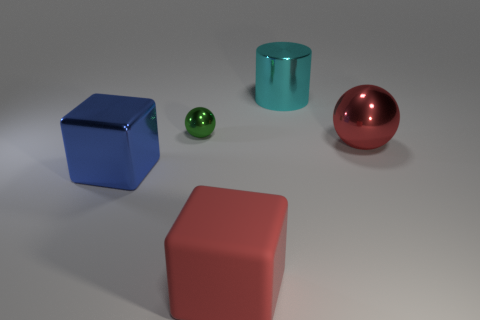Does the small thing have the same color as the large cube that is to the right of the green object?
Give a very brief answer. No. What is the color of the big rubber thing?
Give a very brief answer. Red. There is a ball in front of the tiny green object; what is it made of?
Provide a succinct answer. Metal. The red metal thing that is the same shape as the small green thing is what size?
Offer a very short reply. Large. Is the number of red metal balls behind the green metallic ball less than the number of big red rubber objects?
Offer a very short reply. Yes. Is there a large cyan metallic sphere?
Provide a short and direct response. No. What is the color of the metallic object that is the same shape as the red rubber object?
Keep it short and to the point. Blue. There is a metal thing that is in front of the large red metallic object; does it have the same color as the big metallic sphere?
Provide a short and direct response. No. Does the matte block have the same size as the metallic cube?
Your answer should be compact. Yes. There is a tiny green thing that is the same material as the big blue object; what shape is it?
Give a very brief answer. Sphere. 